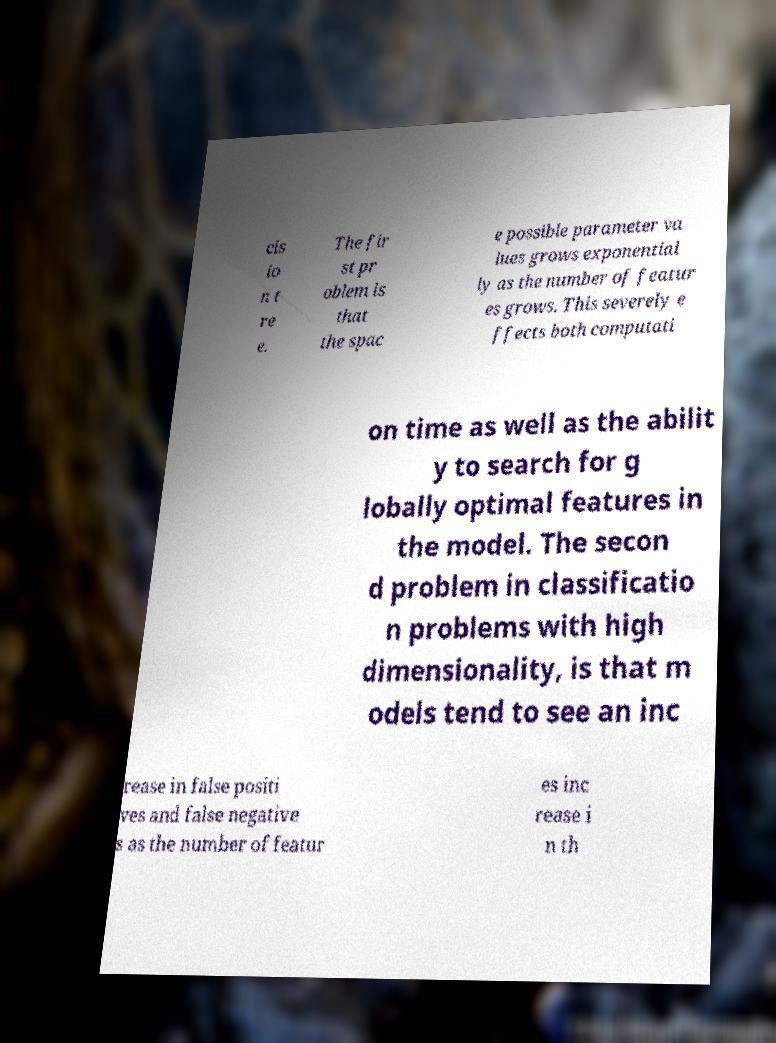I need the written content from this picture converted into text. Can you do that? cis io n t re e. The fir st pr oblem is that the spac e possible parameter va lues grows exponential ly as the number of featur es grows. This severely e ffects both computati on time as well as the abilit y to search for g lobally optimal features in the model. The secon d problem in classificatio n problems with high dimensionality, is that m odels tend to see an inc rease in false positi ves and false negative s as the number of featur es inc rease i n th 